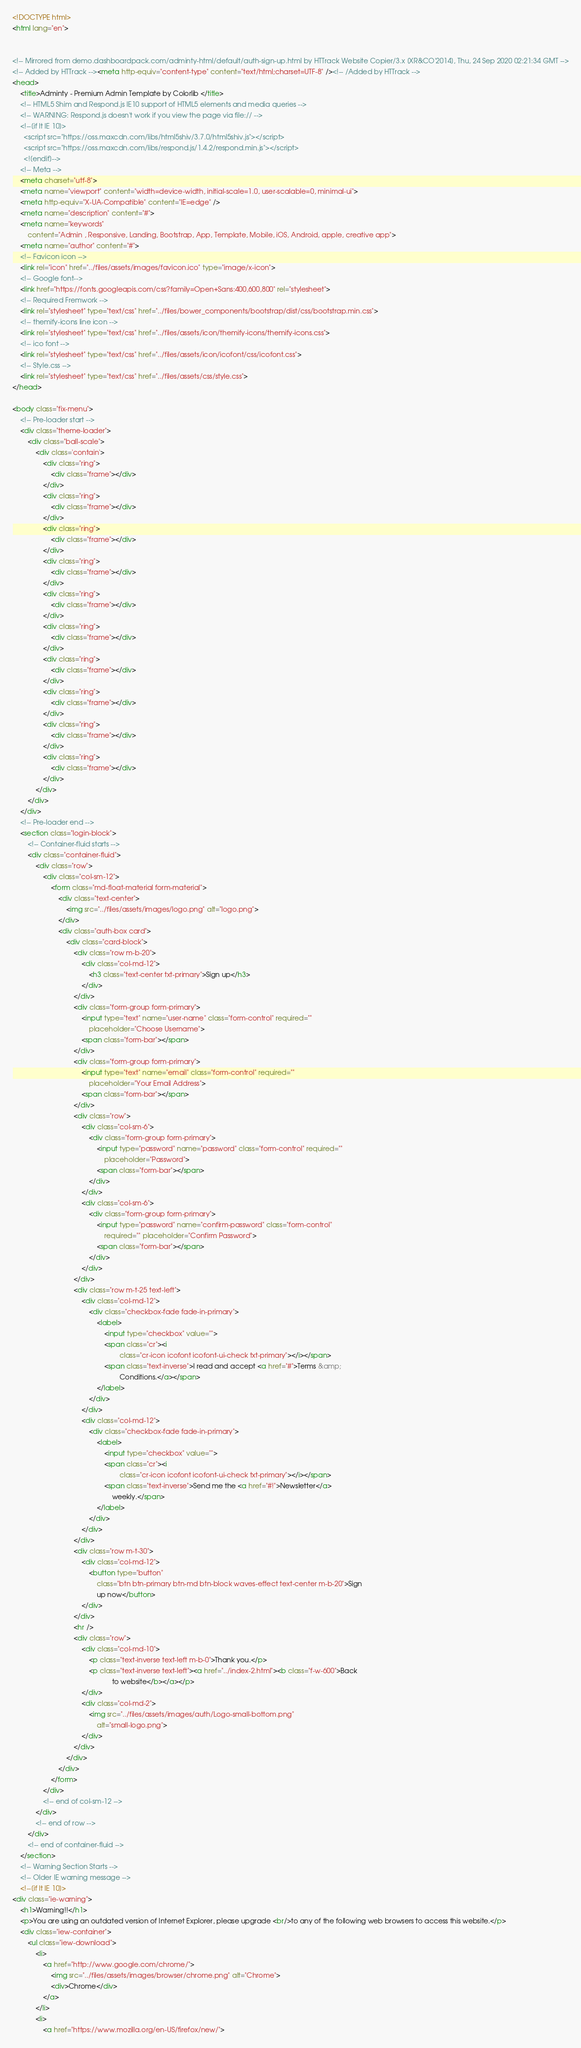Convert code to text. <code><loc_0><loc_0><loc_500><loc_500><_HTML_><!DOCTYPE html>
<html lang="en">


<!-- Mirrored from demo.dashboardpack.com/adminty-html/default/auth-sign-up.html by HTTrack Website Copier/3.x [XR&CO'2014], Thu, 24 Sep 2020 02:21:34 GMT -->
<!-- Added by HTTrack --><meta http-equiv="content-type" content="text/html;charset=UTF-8" /><!-- /Added by HTTrack -->
<head>
    <title>Adminty - Premium Admin Template by Colorlib </title>
    <!-- HTML5 Shim and Respond.js IE10 support of HTML5 elements and media queries -->
    <!-- WARNING: Respond.js doesn't work if you view the page via file:// -->
    <!--[if lt IE 10]>
      <script src="https://oss.maxcdn.com/libs/html5shiv/3.7.0/html5shiv.js"></script>
      <script src="https://oss.maxcdn.com/libs/respond.js/1.4.2/respond.min.js"></script>
      <![endif]-->
    <!-- Meta -->
    <meta charset="utf-8">
    <meta name="viewport" content="width=device-width, initial-scale=1.0, user-scalable=0, minimal-ui">
    <meta http-equiv="X-UA-Compatible" content="IE=edge" />
    <meta name="description" content="#">
    <meta name="keywords"
        content="Admin , Responsive, Landing, Bootstrap, App, Template, Mobile, iOS, Android, apple, creative app">
    <meta name="author" content="#">
    <!-- Favicon icon -->
    <link rel="icon" href="../files/assets/images/favicon.ico" type="image/x-icon">
    <!-- Google font-->
    <link href="https://fonts.googleapis.com/css?family=Open+Sans:400,600,800" rel="stylesheet">
    <!-- Required Fremwork -->
    <link rel="stylesheet" type="text/css" href="../files/bower_components/bootstrap/dist/css/bootstrap.min.css">
    <!-- themify-icons line icon -->
    <link rel="stylesheet" type="text/css" href="../files/assets/icon/themify-icons/themify-icons.css">
    <!-- ico font -->
    <link rel="stylesheet" type="text/css" href="../files/assets/icon/icofont/css/icofont.css">
    <!-- Style.css -->
    <link rel="stylesheet" type="text/css" href="../files/assets/css/style.css">
</head>

<body class="fix-menu">
    <!-- Pre-loader start -->
    <div class="theme-loader">
        <div class="ball-scale">
            <div class='contain'>
                <div class="ring">
                    <div class="frame"></div>
                </div>
                <div class="ring">
                    <div class="frame"></div>
                </div>
                <div class="ring">
                    <div class="frame"></div>
                </div>
                <div class="ring">
                    <div class="frame"></div>
                </div>
                <div class="ring">
                    <div class="frame"></div>
                </div>
                <div class="ring">
                    <div class="frame"></div>
                </div>
                <div class="ring">
                    <div class="frame"></div>
                </div>
                <div class="ring">
                    <div class="frame"></div>
                </div>
                <div class="ring">
                    <div class="frame"></div>
                </div>
                <div class="ring">
                    <div class="frame"></div>
                </div>
            </div>
        </div>
    </div>
    <!-- Pre-loader end -->
    <section class="login-block">
        <!-- Container-fluid starts -->
        <div class="container-fluid">
            <div class="row">
                <div class="col-sm-12">
                    <form class="md-float-material form-material">
                        <div class="text-center">
                            <img src="../files/assets/images/logo.png" alt="logo.png">
                        </div>
                        <div class="auth-box card">
                            <div class="card-block">
                                <div class="row m-b-20">
                                    <div class="col-md-12">
                                        <h3 class="text-center txt-primary">Sign up</h3>
                                    </div>
                                </div>
                                <div class="form-group form-primary">
                                    <input type="text" name="user-name" class="form-control" required=""
                                        placeholder="Choose Username">
                                    <span class="form-bar"></span>
                                </div>
                                <div class="form-group form-primary">
                                    <input type="text" name="email" class="form-control" required=""
                                        placeholder="Your Email Address">
                                    <span class="form-bar"></span>
                                </div>
                                <div class="row">
                                    <div class="col-sm-6">
                                        <div class="form-group form-primary">
                                            <input type="password" name="password" class="form-control" required=""
                                                placeholder="Password">
                                            <span class="form-bar"></span>
                                        </div>
                                    </div>
                                    <div class="col-sm-6">
                                        <div class="form-group form-primary">
                                            <input type="password" name="confirm-password" class="form-control"
                                                required="" placeholder="Confirm Password">
                                            <span class="form-bar"></span>
                                        </div>
                                    </div>
                                </div>
                                <div class="row m-t-25 text-left">
                                    <div class="col-md-12">
                                        <div class="checkbox-fade fade-in-primary">
                                            <label>
                                                <input type="checkbox" value="">
                                                <span class="cr"><i
                                                        class="cr-icon icofont icofont-ui-check txt-primary"></i></span>
                                                <span class="text-inverse">I read and accept <a href="#">Terms &amp;
                                                        Conditions.</a></span>
                                            </label>
                                        </div>
                                    </div>
                                    <div class="col-md-12">
                                        <div class="checkbox-fade fade-in-primary">
                                            <label>
                                                <input type="checkbox" value="">
                                                <span class="cr"><i
                                                        class="cr-icon icofont icofont-ui-check txt-primary"></i></span>
                                                <span class="text-inverse">Send me the <a href="#!">Newsletter</a>
                                                    weekly.</span>
                                            </label>
                                        </div>
                                    </div>
                                </div>
                                <div class="row m-t-30">
                                    <div class="col-md-12">
                                        <button type="button"
                                            class="btn btn-primary btn-md btn-block waves-effect text-center m-b-20">Sign
                                            up now</button>
                                    </div>
                                </div>
                                <hr />
                                <div class="row">
                                    <div class="col-md-10">
                                        <p class="text-inverse text-left m-b-0">Thank you.</p>
                                        <p class="text-inverse text-left"><a href="../index-2.html"><b class="f-w-600">Back
                                                    to website</b></a></p>
                                    </div>
                                    <div class="col-md-2">
                                        <img src="../files/assets/images/auth/Logo-small-bottom.png"
                                            alt="small-logo.png">
                                    </div>
                                </div>
                            </div>
                        </div>
                    </form>
                </div>
                <!-- end of col-sm-12 -->
            </div>
            <!-- end of row -->
        </div>
        <!-- end of container-fluid -->
    </section>
    <!-- Warning Section Starts -->
    <!-- Older IE warning message -->
    <!--[if lt IE 10]>
<div class="ie-warning">
    <h1>Warning!!</h1>
    <p>You are using an outdated version of Internet Explorer, please upgrade <br/>to any of the following web browsers to access this website.</p>
    <div class="iew-container">
        <ul class="iew-download">
            <li>
                <a href="http://www.google.com/chrome/">
                    <img src="../files/assets/images/browser/chrome.png" alt="Chrome">
                    <div>Chrome</div>
                </a>
            </li>
            <li>
                <a href="https://www.mozilla.org/en-US/firefox/new/"></code> 